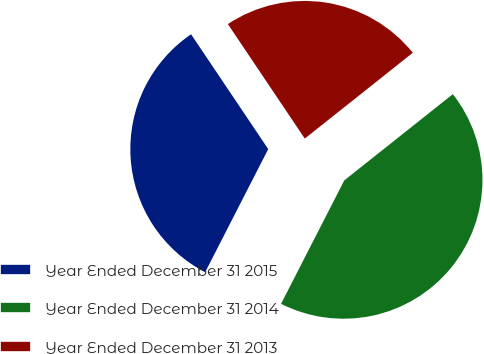Convert chart to OTSL. <chart><loc_0><loc_0><loc_500><loc_500><pie_chart><fcel>Year Ended December 31 2015<fcel>Year Ended December 31 2014<fcel>Year Ended December 31 2013<nl><fcel>33.05%<fcel>43.22%<fcel>23.73%<nl></chart> 